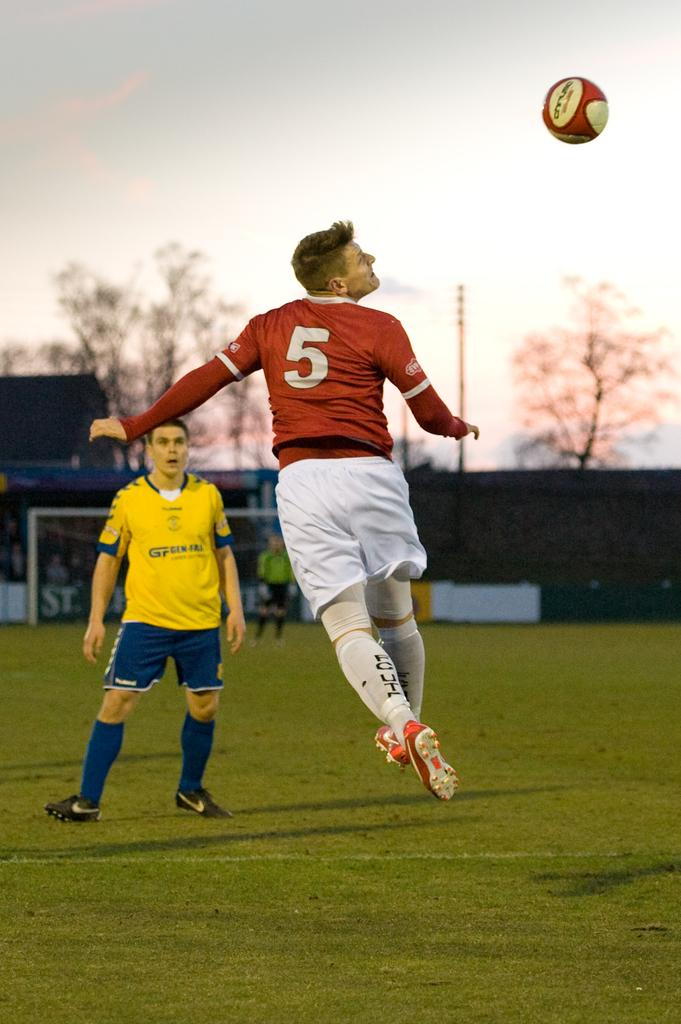<image>
Describe the image concisely. Soccer player number 5 jumps in the air looking at the soccer ball. 